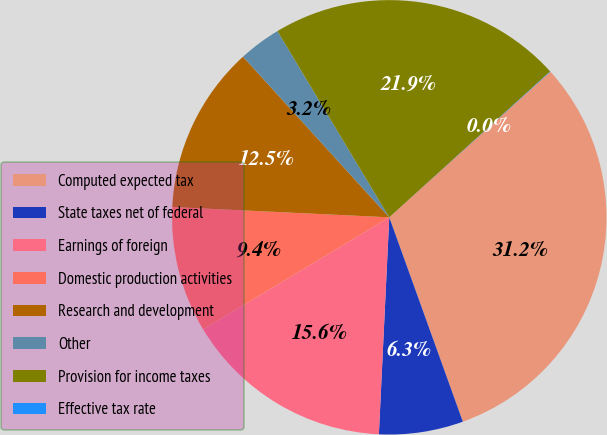Convert chart to OTSL. <chart><loc_0><loc_0><loc_500><loc_500><pie_chart><fcel>Computed expected tax<fcel>State taxes net of federal<fcel>Earnings of foreign<fcel>Domestic production activities<fcel>Research and development<fcel>Other<fcel>Provision for income taxes<fcel>Effective tax rate<nl><fcel>31.19%<fcel>6.26%<fcel>15.61%<fcel>9.38%<fcel>12.49%<fcel>3.15%<fcel>21.88%<fcel>0.03%<nl></chart> 